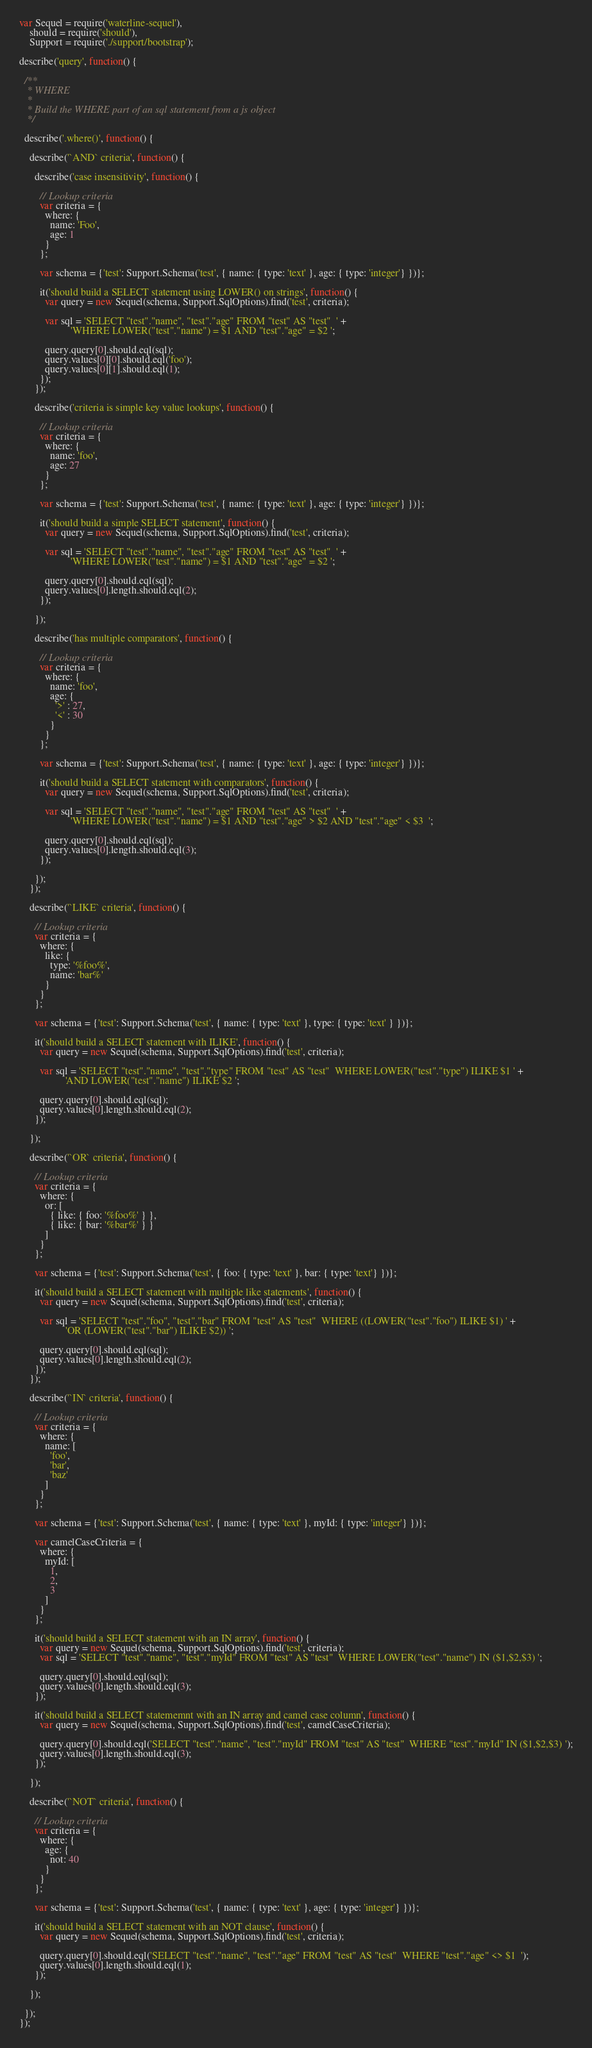Convert code to text. <code><loc_0><loc_0><loc_500><loc_500><_JavaScript_>var Sequel = require('waterline-sequel'),
    should = require('should'),
    Support = require('./support/bootstrap');

describe('query', function() {

  /**
   * WHERE
   *
   * Build the WHERE part of an sql statement from a js object
   */

  describe('.where()', function() {

    describe('`AND` criteria', function() {

      describe('case insensitivity', function() {

        // Lookup criteria
        var criteria = {
          where: {
            name: 'Foo',
            age: 1
          }
        };

        var schema = {'test': Support.Schema('test', { name: { type: 'text' }, age: { type: 'integer'} })};

        it('should build a SELECT statement using LOWER() on strings', function() {
          var query = new Sequel(schema, Support.SqlOptions).find('test', criteria);

          var sql = 'SELECT "test"."name", "test"."age" FROM "test" AS "test"  ' +
                    'WHERE LOWER("test"."name") = $1 AND "test"."age" = $2 ';

          query.query[0].should.eql(sql);
          query.values[0][0].should.eql('foo');
          query.values[0][1].should.eql(1);
        });
      });

      describe('criteria is simple key value lookups', function() {

        // Lookup criteria
        var criteria = {
          where: {
            name: 'foo',
            age: 27
          }
        };

        var schema = {'test': Support.Schema('test', { name: { type: 'text' }, age: { type: 'integer'} })};

        it('should build a simple SELECT statement', function() {
          var query = new Sequel(schema, Support.SqlOptions).find('test', criteria);

          var sql = 'SELECT "test"."name", "test"."age" FROM "test" AS "test"  ' +
                    'WHERE LOWER("test"."name") = $1 AND "test"."age" = $2 ';

          query.query[0].should.eql(sql);
          query.values[0].length.should.eql(2);
        });

      });

      describe('has multiple comparators', function() {

        // Lookup criteria
        var criteria = {
          where: {
            name: 'foo',
            age: {
              '>' : 27,
              '<' : 30
            }
          }
        };

        var schema = {'test': Support.Schema('test', { name: { type: 'text' }, age: { type: 'integer'} })};

        it('should build a SELECT statement with comparators', function() {
          var query = new Sequel(schema, Support.SqlOptions).find('test', criteria);

          var sql = 'SELECT "test"."name", "test"."age" FROM "test" AS "test"  ' +
                    'WHERE LOWER("test"."name") = $1 AND "test"."age" > $2 AND "test"."age" < $3  ';

          query.query[0].should.eql(sql);
          query.values[0].length.should.eql(3);
        });

      });
    });

    describe('`LIKE` criteria', function() {

      // Lookup criteria
      var criteria = {
        where: {
          like: {
            type: '%foo%',
            name: 'bar%'
          }
        }
      };

      var schema = {'test': Support.Schema('test', { name: { type: 'text' }, type: { type: 'text' } })};

      it('should build a SELECT statement with ILIKE', function() {
        var query = new Sequel(schema, Support.SqlOptions).find('test', criteria);

        var sql = 'SELECT "test"."name", "test"."type" FROM "test" AS "test"  WHERE LOWER("test"."type") ILIKE $1 ' +
                  'AND LOWER("test"."name") ILIKE $2 ';

        query.query[0].should.eql(sql);
        query.values[0].length.should.eql(2);
      });

    });

    describe('`OR` criteria', function() {

      // Lookup criteria
      var criteria = {
        where: {
          or: [
            { like: { foo: '%foo%' } },
            { like: { bar: '%bar%' } }
          ]
        }
      };

      var schema = {'test': Support.Schema('test', { foo: { type: 'text' }, bar: { type: 'text'} })};

      it('should build a SELECT statement with multiple like statements', function() {
        var query = new Sequel(schema, Support.SqlOptions).find('test', criteria);

        var sql = 'SELECT "test"."foo", "test"."bar" FROM "test" AS "test"  WHERE ((LOWER("test"."foo") ILIKE $1) ' +
                  'OR (LOWER("test"."bar") ILIKE $2)) ';

        query.query[0].should.eql(sql);
        query.values[0].length.should.eql(2);
      });
    });

    describe('`IN` criteria', function() {

      // Lookup criteria
      var criteria = {
        where: {
          name: [
            'foo',
            'bar',
            'baz'
          ]
        }
      };

      var schema = {'test': Support.Schema('test', { name: { type: 'text' }, myId: { type: 'integer'} })};

      var camelCaseCriteria = {
        where: {
          myId: [
            1,
            2,
            3
          ]
        }
      };

      it('should build a SELECT statement with an IN array', function() {
        var query = new Sequel(schema, Support.SqlOptions).find('test', criteria);
        var sql = 'SELECT "test"."name", "test"."myId" FROM "test" AS "test"  WHERE LOWER("test"."name") IN ($1,$2,$3) ';

        query.query[0].should.eql(sql);
        query.values[0].length.should.eql(3);
      });

      it('should build a SELECT statememnt with an IN array and camel case column', function() {
        var query = new Sequel(schema, Support.SqlOptions).find('test', camelCaseCriteria);

        query.query[0].should.eql('SELECT "test"."name", "test"."myId" FROM "test" AS "test"  WHERE "test"."myId" IN ($1,$2,$3) ');
        query.values[0].length.should.eql(3);
      });

    });

    describe('`NOT` criteria', function() {

      // Lookup criteria
      var criteria = {
        where: {
          age: {
            not: 40
          }
        }
      };

      var schema = {'test': Support.Schema('test', { name: { type: 'text' }, age: { type: 'integer'} })};

      it('should build a SELECT statement with an NOT clause', function() {
        var query = new Sequel(schema, Support.SqlOptions).find('test', criteria);

        query.query[0].should.eql('SELECT "test"."name", "test"."age" FROM "test" AS "test"  WHERE "test"."age" <> $1  ');
        query.values[0].length.should.eql(1);
      });

    });

  });
});</code> 